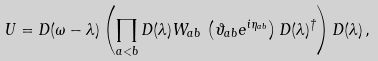Convert formula to latex. <formula><loc_0><loc_0><loc_500><loc_500>U = D ( \omega - \lambda ) \left ( \prod _ { a < b } D ( \lambda ) W _ { a b } \, \left ( \vartheta _ { a b } e ^ { i \eta _ { a b } } \right ) D ( \lambda ) ^ { \dagger } \right ) D ( \lambda ) \, ,</formula> 